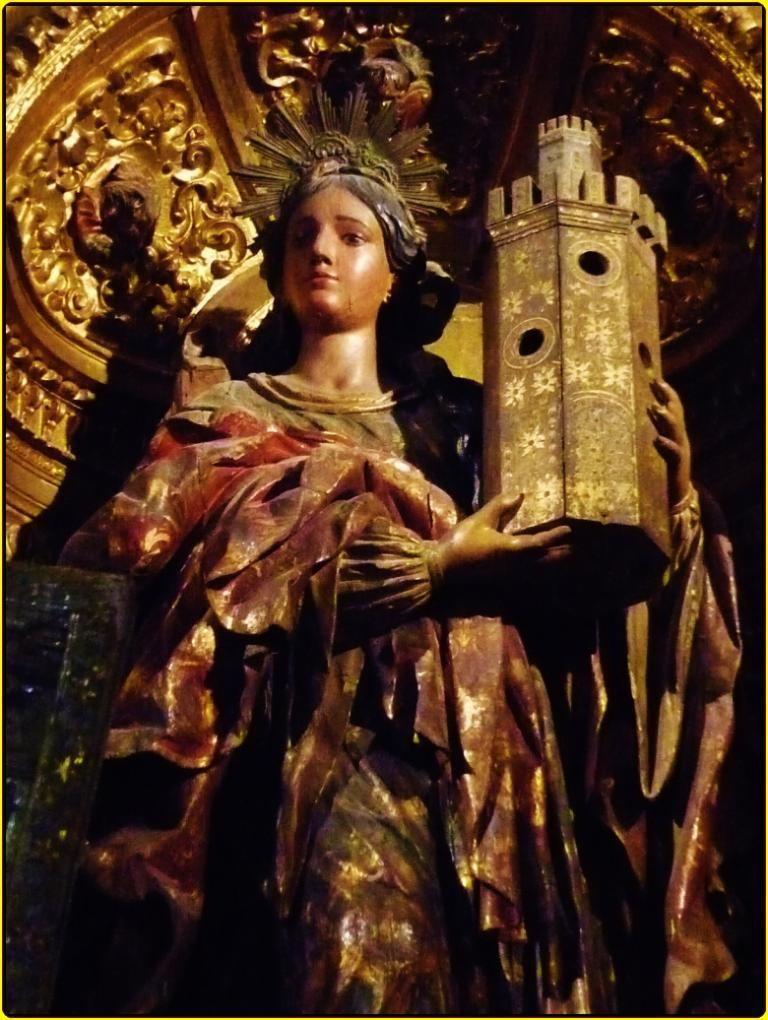What is the main subject of the image? The main subject of the image is an idol of a woman. What is the woman holding in the image? The woman is holding a monument in the image. What type of linen is draped over the monument in the image? There is no linen present in the image; the monument is being held by the woman idol. 